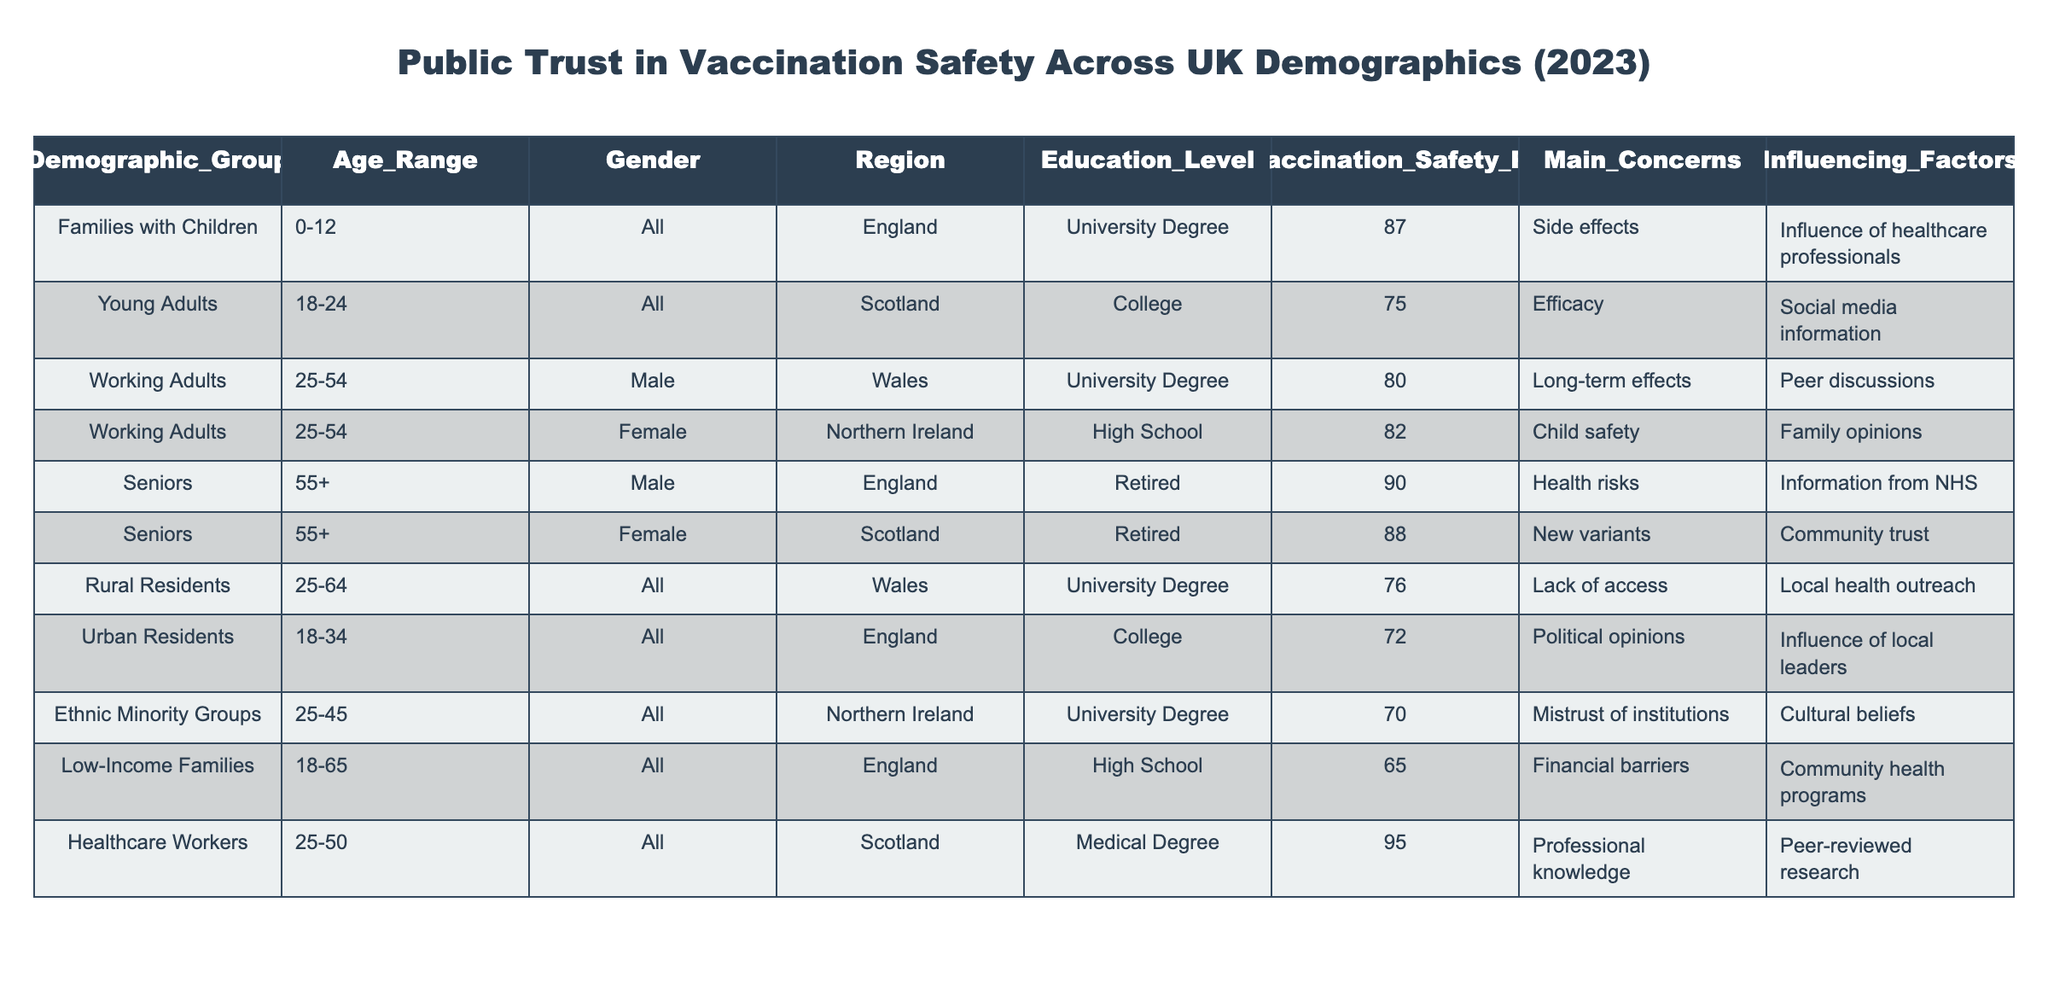What is the trust percentage in vaccination safety for Healthcare Workers? The table provides the trust percentage for Healthcare Workers as 95. This data point is directly retrievable from the respective row under the 'Trust_in_Vaccination_Safety_Percentage' column.
Answer: 95 Which demographic group has the lowest trust in vaccination safety? By examining each demographic group's trust percentages, Low-Income Families have the lowest percentage at 65, which is the smallest value in the 'Trust_in_Vaccination_Safety_Percentage' column.
Answer: Low-Income Families What are the main concerns for Young Adults regarding vaccination safety? The table indicates that for Young Adults, the main concern is Efficacy. This information can be found in the 'Main_Concerns' column corresponding to the Young Adults row.
Answer: Efficacy What is the average trust percentage across all demographics listed? To calculate the average, sum all the trust percentages (87 + 75 + 80 + 82 + 90 + 88 + 76 + 72 + 70 + 65 + 95) which equals  79. The number of groups is 11, leading to an average of 79/11 ≈ 79.
Answer: 79 True or False: Seniors in Scotland have a higher trust percentage in vaccination safety than Working Adults in Wales. The trust percentage for Seniors in Scotland is 88, which is higher than the 80 percentage for Working Adults in Wales. Comparing these two values confirms the statement is True.
Answer: True What percentage of Urban Residents express concerns about political opinions regarding vaccination safety? The table indicates that Urban Residents' main concern is Political opinions, but does not provide a specific percentage related to this concern. Thus, it's not possible to determine a percentage for this concern based on the table.
Answer: Not applicable Which demographic group has a higher trust percentage: Families with Children or Seniors? Families with Children have a trust percentage of 87, while Seniors have a trust percentage of 90. Since 90 is greater than 87, Seniors have a higher percentage.
Answer: Seniors Calculate the difference in trust percentage between Healthcare Workers and Low-Income Families. The trust percentage for Healthcare Workers is 95, and for Low-Income Families, it is 65. The difference is calculated by subtracting the lower value from the higher value (95 - 65), which equals 30.
Answer: 30 What is the trust percentage for Urban Residents? The table indicates that the trust percentage for Urban Residents is 72, as shown in the 'Trust_in_Vaccination_Safety_Percentage' column for that demographic.
Answer: 72 How many demographic groups have a trust percentage of 80 or above? The groups with trust percentages of 80 or above are Families with Children (87), Healthcare Workers (95), Seniors (90, 88), and Working Adults (80, 82). Counting these gives a total of 7 groups.
Answer: 7 